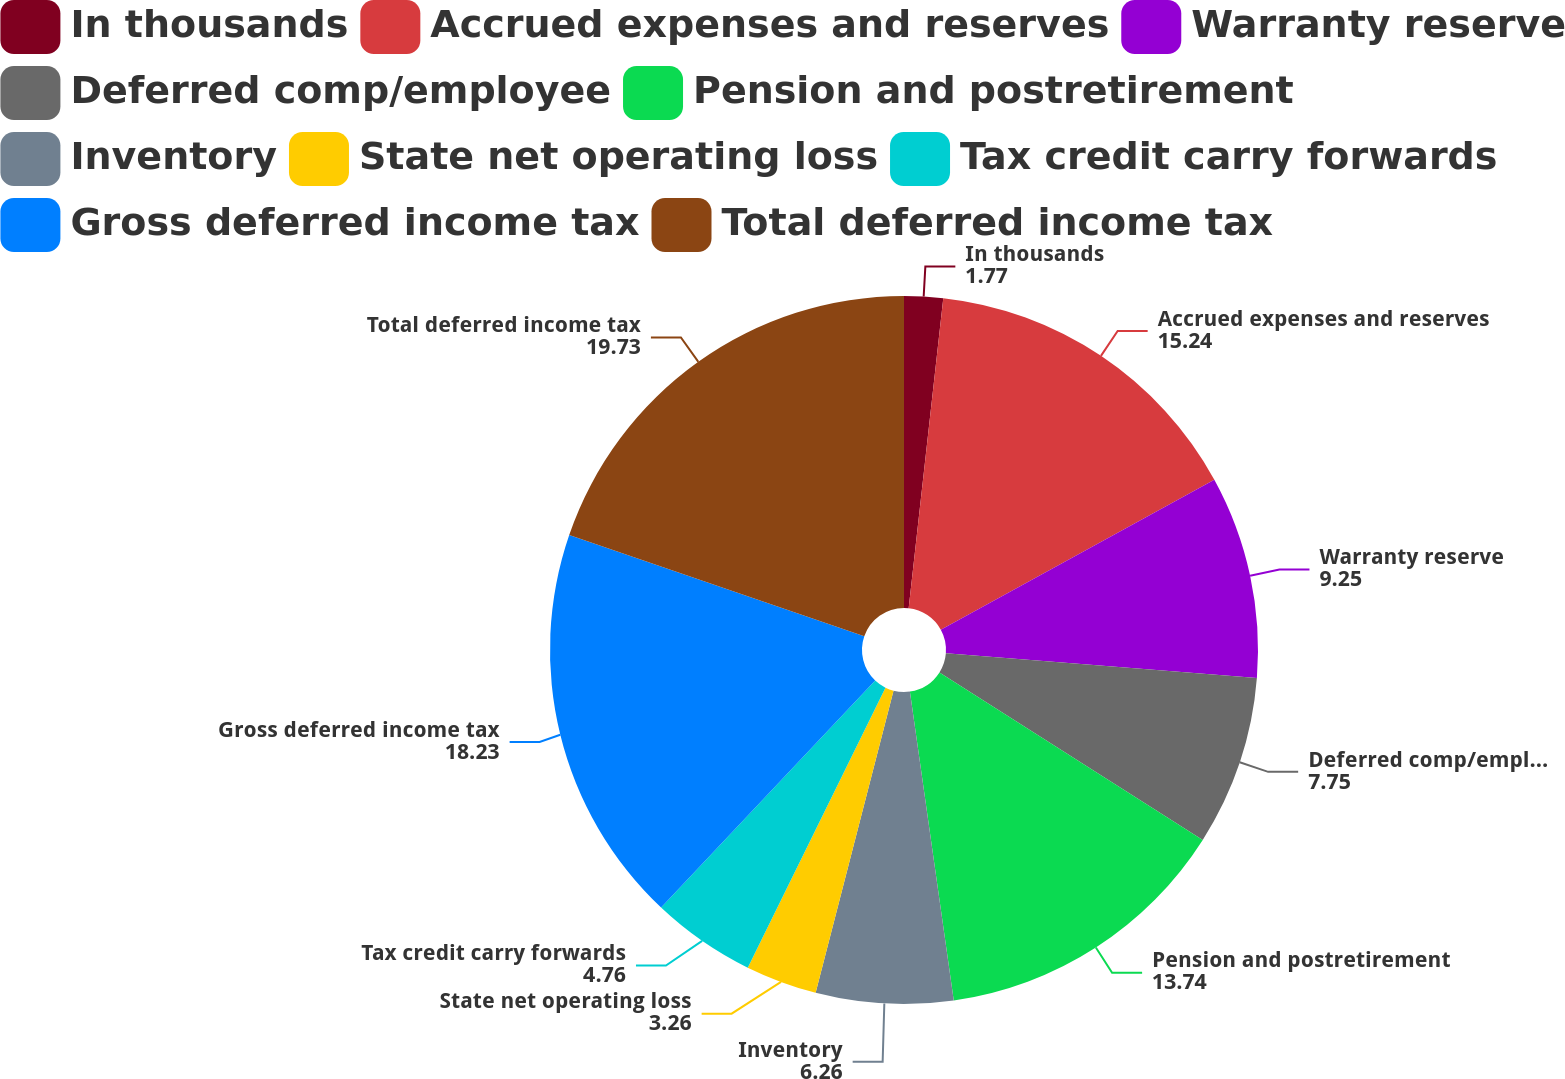Convert chart. <chart><loc_0><loc_0><loc_500><loc_500><pie_chart><fcel>In thousands<fcel>Accrued expenses and reserves<fcel>Warranty reserve<fcel>Deferred comp/employee<fcel>Pension and postretirement<fcel>Inventory<fcel>State net operating loss<fcel>Tax credit carry forwards<fcel>Gross deferred income tax<fcel>Total deferred income tax<nl><fcel>1.77%<fcel>15.24%<fcel>9.25%<fcel>7.75%<fcel>13.74%<fcel>6.26%<fcel>3.26%<fcel>4.76%<fcel>18.23%<fcel>19.73%<nl></chart> 